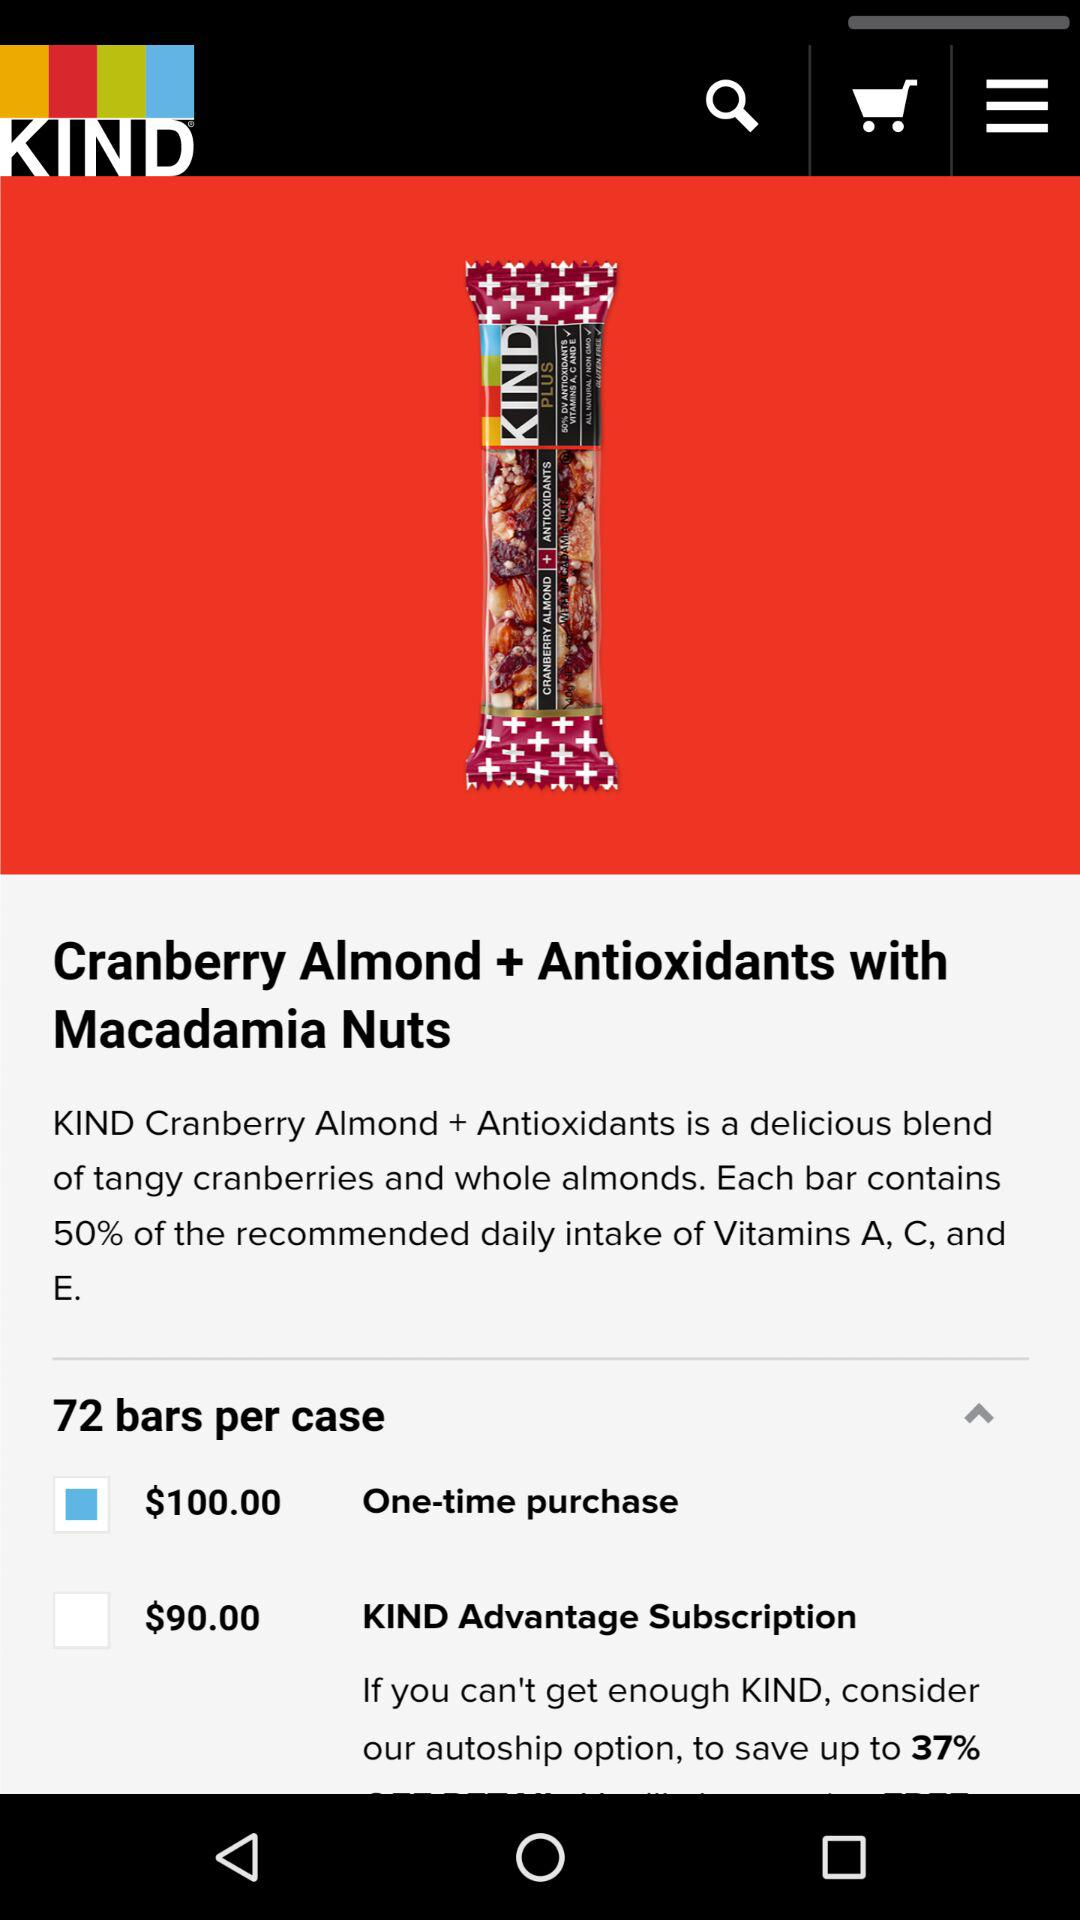Which vitamins are contained in each bar? Each bar contains vitamins A, C, and E. 